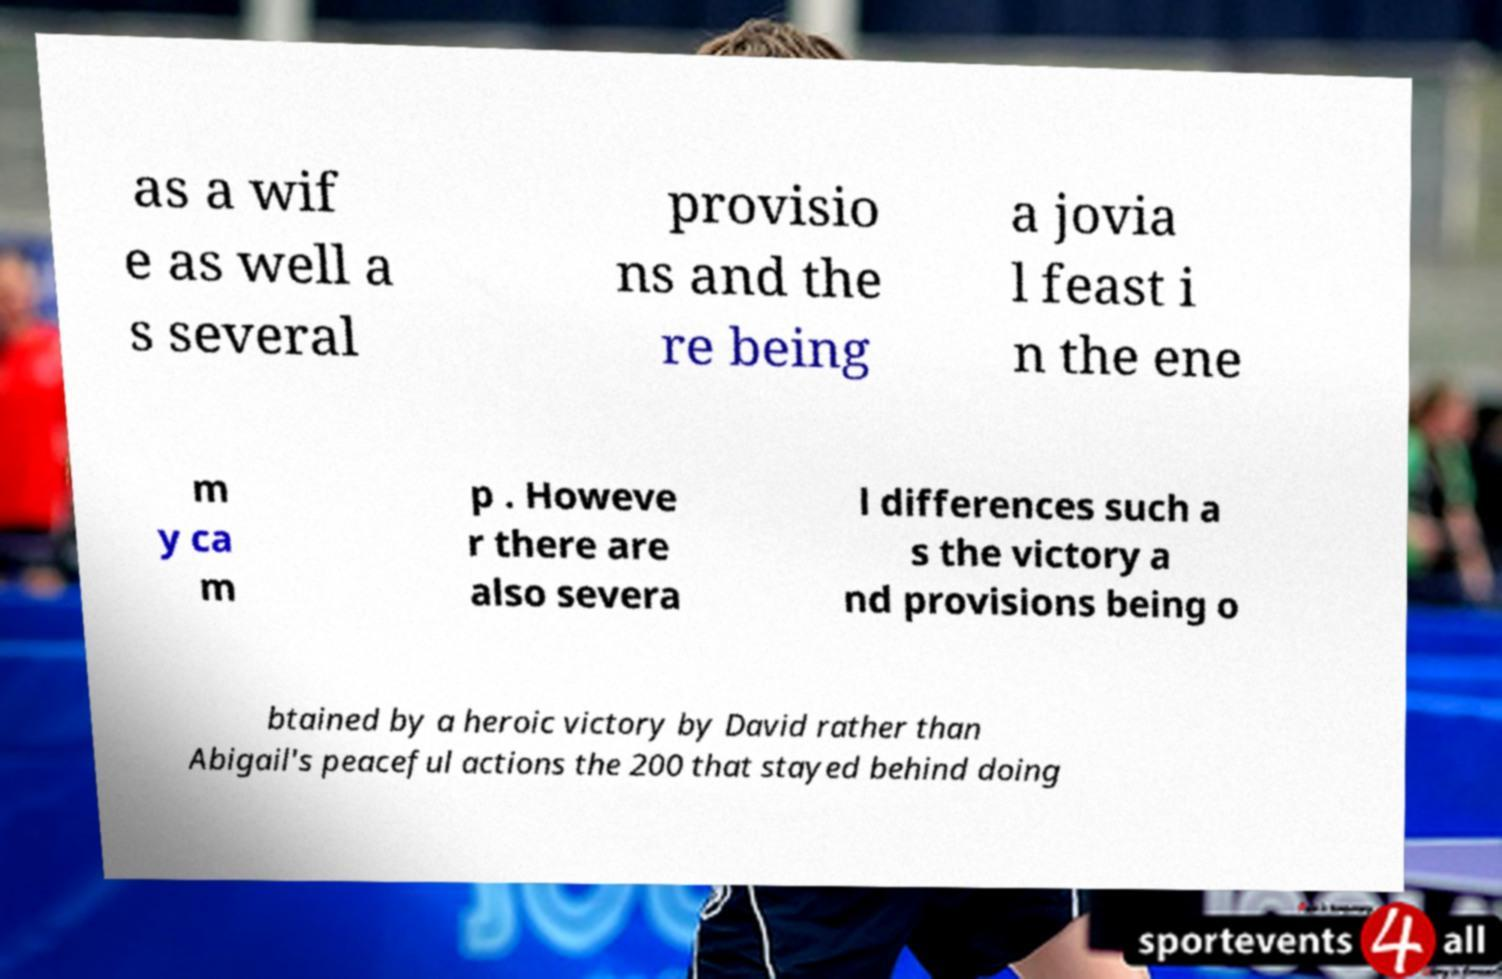Can you read and provide the text displayed in the image?This photo seems to have some interesting text. Can you extract and type it out for me? as a wif e as well a s several provisio ns and the re being a jovia l feast i n the ene m y ca m p . Howeve r there are also severa l differences such a s the victory a nd provisions being o btained by a heroic victory by David rather than Abigail's peaceful actions the 200 that stayed behind doing 